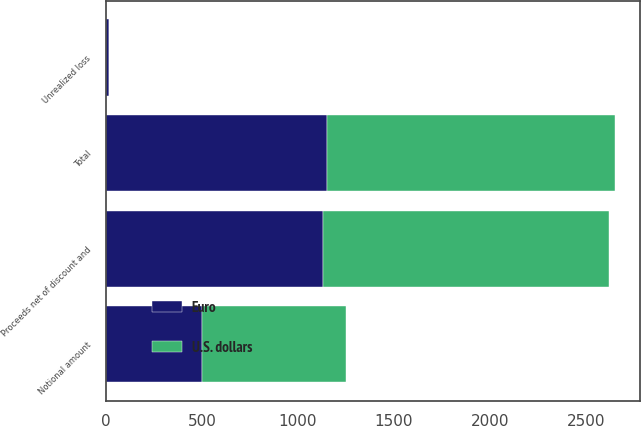<chart> <loc_0><loc_0><loc_500><loc_500><stacked_bar_chart><ecel><fcel>Total<fcel>Proceeds net of discount and<fcel>Notional amount<fcel>Unrealized loss<nl><fcel>U.S. dollars<fcel>1500<fcel>1488<fcel>750<fcel>2<nl><fcel>Euro<fcel>1150<fcel>1133<fcel>500<fcel>16<nl></chart> 